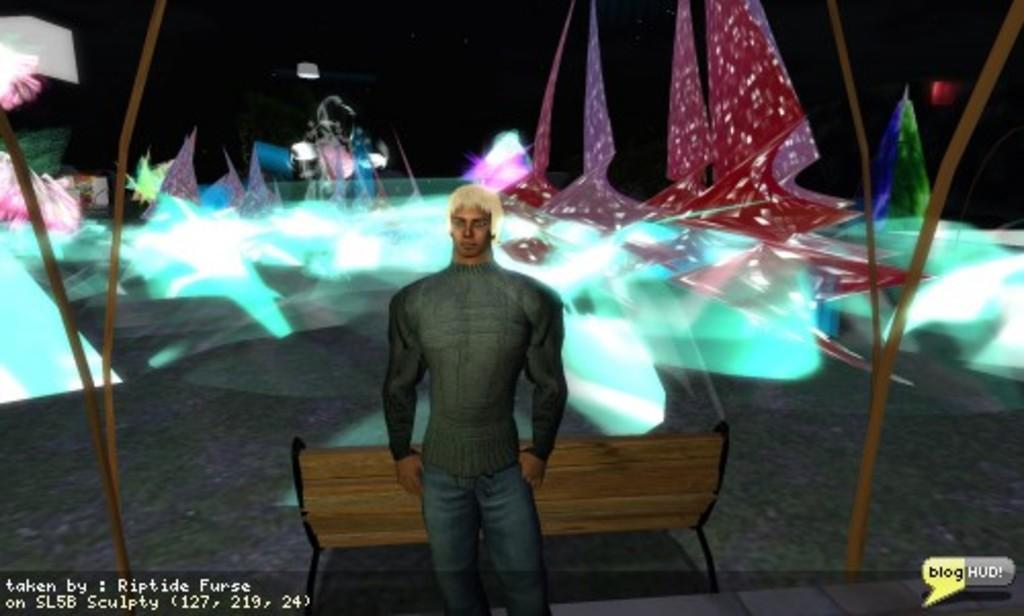Could you give a brief overview of what you see in this image? This is an animated image where there is a person standing , bench, drums, decorative items, and there are watermarks on the image. 